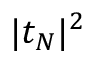Convert formula to latex. <formula><loc_0><loc_0><loc_500><loc_500>| t _ { N } | ^ { 2 }</formula> 